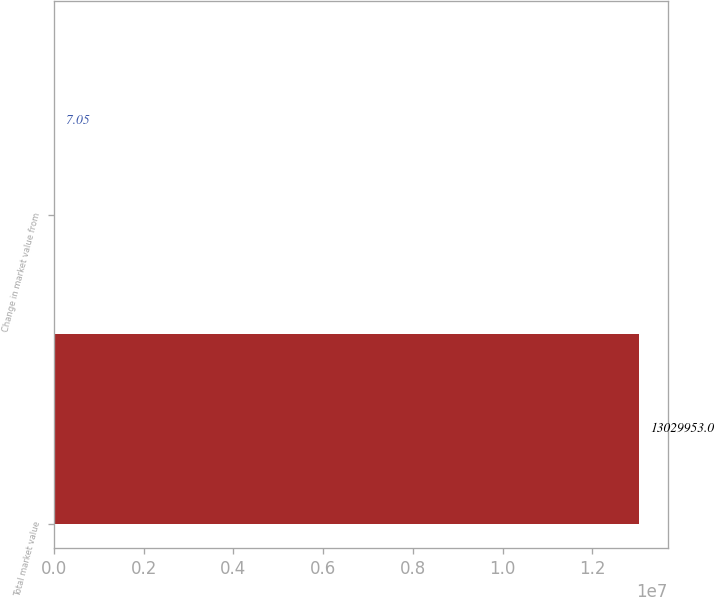Convert chart. <chart><loc_0><loc_0><loc_500><loc_500><bar_chart><fcel>Total market value<fcel>Change in market value from<nl><fcel>1.303e+07<fcel>7.05<nl></chart> 